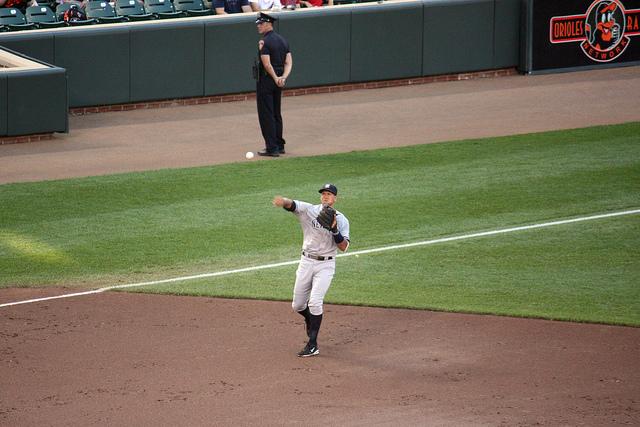What sport is this?
Keep it brief. Baseball. Is the player ready to hit a ball?
Be succinct. No. What sport is being played?
Keep it brief. Baseball. Is this person going to catch the ball with their hand?
Write a very short answer. No. What is the player doing?
Write a very short answer. Throwing ball. What authority figure is standing near the top of this picture?
Quick response, please. Police. Is the player hitting the ball?
Give a very brief answer. No. 